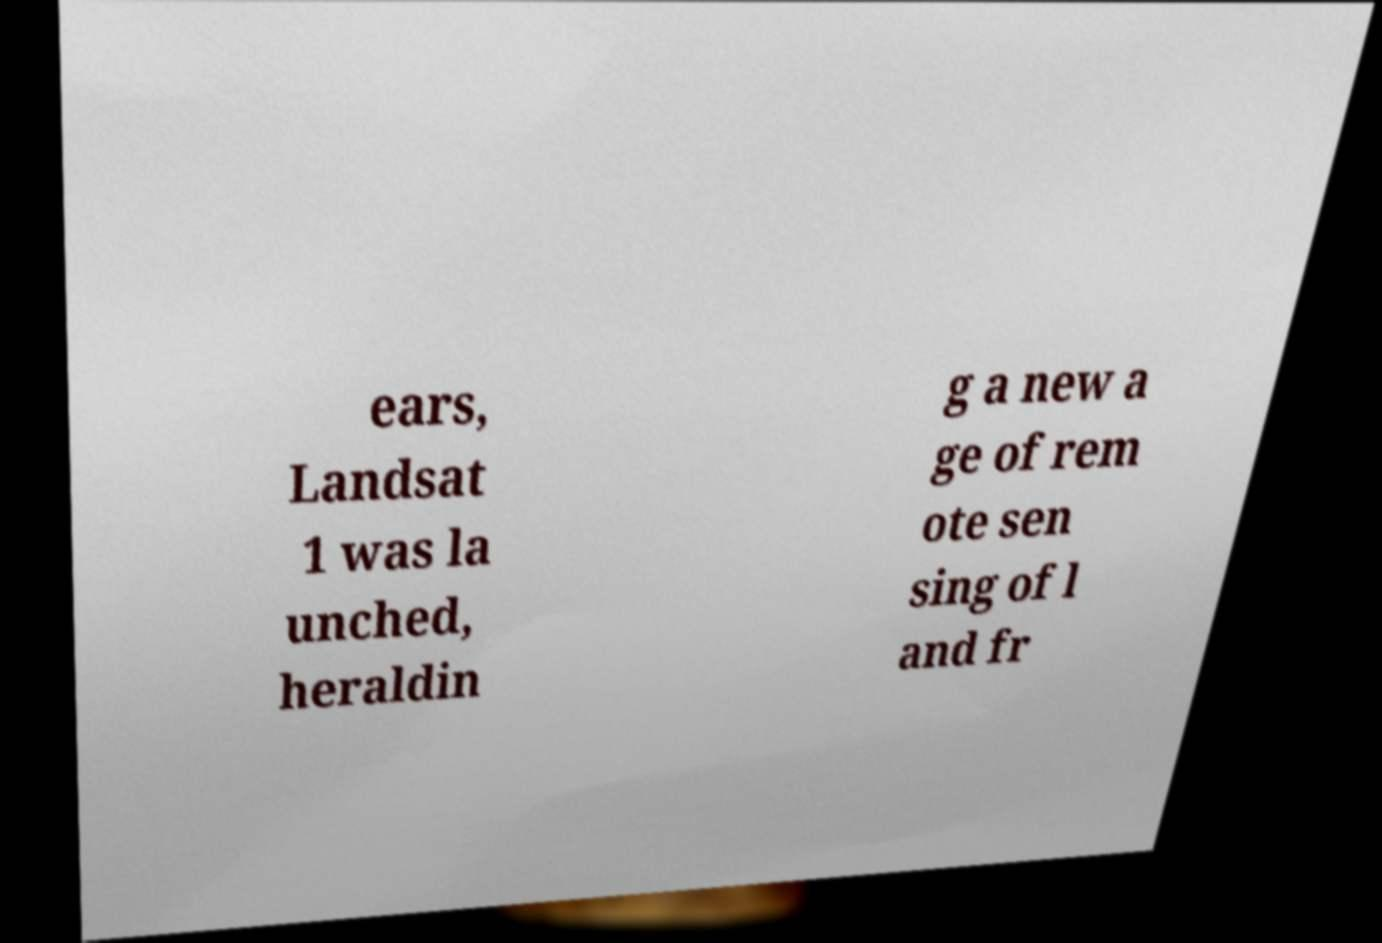Please identify and transcribe the text found in this image. ears, Landsat 1 was la unched, heraldin g a new a ge of rem ote sen sing of l and fr 